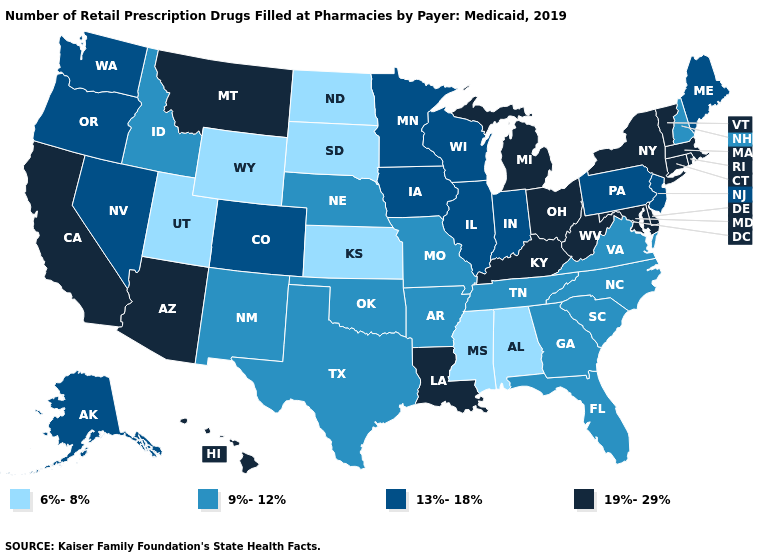What is the lowest value in the USA?
Keep it brief. 6%-8%. Name the states that have a value in the range 6%-8%?
Be succinct. Alabama, Kansas, Mississippi, North Dakota, South Dakota, Utah, Wyoming. What is the lowest value in the USA?
Answer briefly. 6%-8%. What is the value of Vermont?
Short answer required. 19%-29%. What is the value of Montana?
Be succinct. 19%-29%. Is the legend a continuous bar?
Quick response, please. No. Which states have the lowest value in the MidWest?
Concise answer only. Kansas, North Dakota, South Dakota. Does the map have missing data?
Give a very brief answer. No. Does Georgia have the highest value in the South?
Answer briefly. No. What is the highest value in the USA?
Concise answer only. 19%-29%. Does North Carolina have the same value as Missouri?
Be succinct. Yes. Name the states that have a value in the range 9%-12%?
Give a very brief answer. Arkansas, Florida, Georgia, Idaho, Missouri, Nebraska, New Hampshire, New Mexico, North Carolina, Oklahoma, South Carolina, Tennessee, Texas, Virginia. Name the states that have a value in the range 6%-8%?
Give a very brief answer. Alabama, Kansas, Mississippi, North Dakota, South Dakota, Utah, Wyoming. Does Pennsylvania have the highest value in the USA?
Give a very brief answer. No. Which states have the highest value in the USA?
Short answer required. Arizona, California, Connecticut, Delaware, Hawaii, Kentucky, Louisiana, Maryland, Massachusetts, Michigan, Montana, New York, Ohio, Rhode Island, Vermont, West Virginia. 